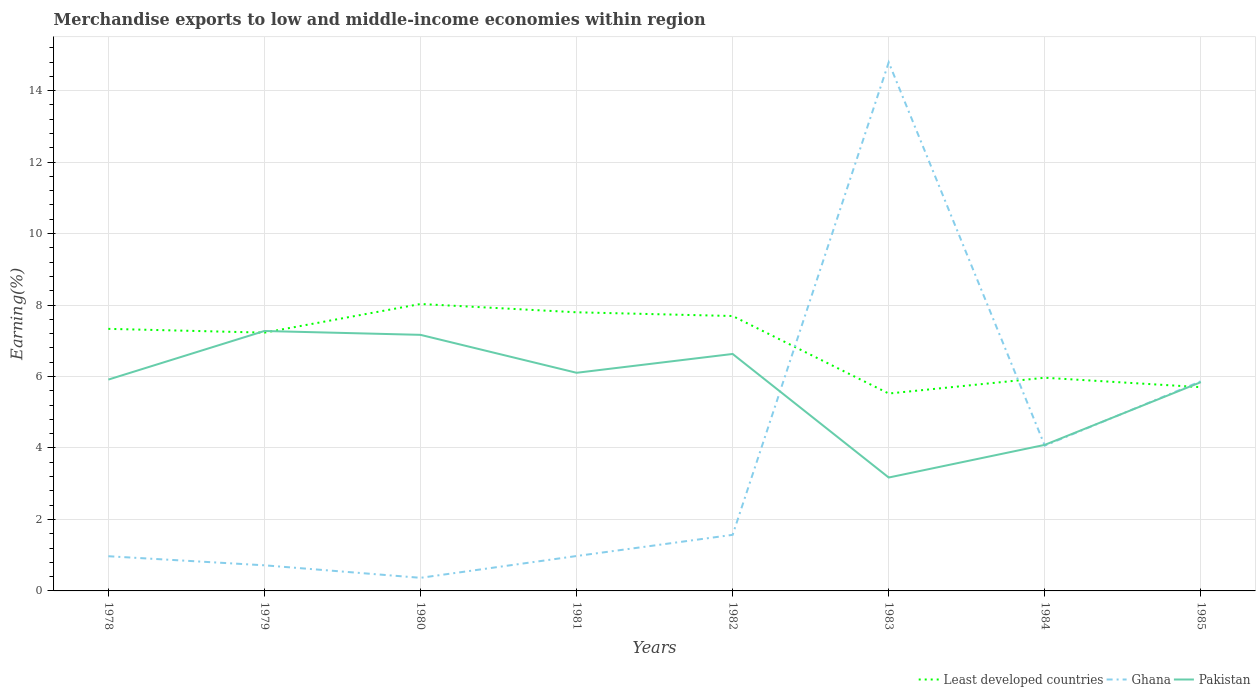How many different coloured lines are there?
Your answer should be compact. 3. Does the line corresponding to Ghana intersect with the line corresponding to Pakistan?
Your answer should be very brief. Yes. Across all years, what is the maximum percentage of amount earned from merchandise exports in Pakistan?
Give a very brief answer. 3.17. In which year was the percentage of amount earned from merchandise exports in Pakistan maximum?
Give a very brief answer. 1983. What is the total percentage of amount earned from merchandise exports in Pakistan in the graph?
Offer a very short reply. 3.08. What is the difference between the highest and the second highest percentage of amount earned from merchandise exports in Least developed countries?
Ensure brevity in your answer.  2.51. What is the difference between the highest and the lowest percentage of amount earned from merchandise exports in Ghana?
Offer a very short reply. 3. Is the percentage of amount earned from merchandise exports in Ghana strictly greater than the percentage of amount earned from merchandise exports in Pakistan over the years?
Your response must be concise. No. Does the graph contain any zero values?
Keep it short and to the point. No. Does the graph contain grids?
Offer a very short reply. Yes. Where does the legend appear in the graph?
Offer a terse response. Bottom right. How many legend labels are there?
Your answer should be compact. 3. How are the legend labels stacked?
Your answer should be very brief. Horizontal. What is the title of the graph?
Give a very brief answer. Merchandise exports to low and middle-income economies within region. Does "Argentina" appear as one of the legend labels in the graph?
Keep it short and to the point. No. What is the label or title of the Y-axis?
Make the answer very short. Earning(%). What is the Earning(%) in Least developed countries in 1978?
Offer a very short reply. 7.33. What is the Earning(%) in Ghana in 1978?
Offer a very short reply. 0.97. What is the Earning(%) of Pakistan in 1978?
Your answer should be compact. 5.91. What is the Earning(%) in Least developed countries in 1979?
Your answer should be very brief. 7.23. What is the Earning(%) in Ghana in 1979?
Your answer should be compact. 0.72. What is the Earning(%) in Pakistan in 1979?
Offer a very short reply. 7.27. What is the Earning(%) in Least developed countries in 1980?
Offer a very short reply. 8.03. What is the Earning(%) in Ghana in 1980?
Provide a short and direct response. 0.37. What is the Earning(%) of Pakistan in 1980?
Keep it short and to the point. 7.17. What is the Earning(%) of Least developed countries in 1981?
Your answer should be compact. 7.8. What is the Earning(%) of Ghana in 1981?
Provide a succinct answer. 0.98. What is the Earning(%) of Pakistan in 1981?
Provide a succinct answer. 6.1. What is the Earning(%) of Least developed countries in 1982?
Offer a terse response. 7.69. What is the Earning(%) of Ghana in 1982?
Your response must be concise. 1.57. What is the Earning(%) of Pakistan in 1982?
Provide a short and direct response. 6.63. What is the Earning(%) in Least developed countries in 1983?
Ensure brevity in your answer.  5.52. What is the Earning(%) of Ghana in 1983?
Provide a short and direct response. 14.79. What is the Earning(%) of Pakistan in 1983?
Your response must be concise. 3.17. What is the Earning(%) of Least developed countries in 1984?
Provide a short and direct response. 5.97. What is the Earning(%) of Ghana in 1984?
Offer a terse response. 4.07. What is the Earning(%) of Pakistan in 1984?
Provide a short and direct response. 4.09. What is the Earning(%) of Least developed countries in 1985?
Ensure brevity in your answer.  5.7. What is the Earning(%) of Ghana in 1985?
Your answer should be compact. 5.87. What is the Earning(%) in Pakistan in 1985?
Your answer should be compact. 5.84. Across all years, what is the maximum Earning(%) of Least developed countries?
Your response must be concise. 8.03. Across all years, what is the maximum Earning(%) of Ghana?
Ensure brevity in your answer.  14.79. Across all years, what is the maximum Earning(%) of Pakistan?
Your answer should be compact. 7.27. Across all years, what is the minimum Earning(%) in Least developed countries?
Your response must be concise. 5.52. Across all years, what is the minimum Earning(%) in Ghana?
Provide a succinct answer. 0.37. Across all years, what is the minimum Earning(%) of Pakistan?
Your response must be concise. 3.17. What is the total Earning(%) in Least developed countries in the graph?
Provide a succinct answer. 55.27. What is the total Earning(%) in Ghana in the graph?
Offer a terse response. 29.32. What is the total Earning(%) in Pakistan in the graph?
Your answer should be very brief. 46.19. What is the difference between the Earning(%) of Least developed countries in 1978 and that in 1979?
Ensure brevity in your answer.  0.11. What is the difference between the Earning(%) of Ghana in 1978 and that in 1979?
Your answer should be very brief. 0.25. What is the difference between the Earning(%) of Pakistan in 1978 and that in 1979?
Your answer should be compact. -1.36. What is the difference between the Earning(%) of Least developed countries in 1978 and that in 1980?
Your answer should be compact. -0.7. What is the difference between the Earning(%) of Ghana in 1978 and that in 1980?
Provide a short and direct response. 0.6. What is the difference between the Earning(%) of Pakistan in 1978 and that in 1980?
Make the answer very short. -1.25. What is the difference between the Earning(%) in Least developed countries in 1978 and that in 1981?
Offer a terse response. -0.46. What is the difference between the Earning(%) in Ghana in 1978 and that in 1981?
Keep it short and to the point. -0.01. What is the difference between the Earning(%) in Pakistan in 1978 and that in 1981?
Your response must be concise. -0.19. What is the difference between the Earning(%) of Least developed countries in 1978 and that in 1982?
Provide a short and direct response. -0.36. What is the difference between the Earning(%) of Ghana in 1978 and that in 1982?
Make the answer very short. -0.6. What is the difference between the Earning(%) in Pakistan in 1978 and that in 1982?
Your answer should be very brief. -0.72. What is the difference between the Earning(%) in Least developed countries in 1978 and that in 1983?
Provide a succinct answer. 1.81. What is the difference between the Earning(%) of Ghana in 1978 and that in 1983?
Keep it short and to the point. -13.82. What is the difference between the Earning(%) in Pakistan in 1978 and that in 1983?
Provide a succinct answer. 2.74. What is the difference between the Earning(%) in Least developed countries in 1978 and that in 1984?
Offer a terse response. 1.37. What is the difference between the Earning(%) of Ghana in 1978 and that in 1984?
Give a very brief answer. -3.1. What is the difference between the Earning(%) in Pakistan in 1978 and that in 1984?
Keep it short and to the point. 1.83. What is the difference between the Earning(%) of Least developed countries in 1978 and that in 1985?
Ensure brevity in your answer.  1.63. What is the difference between the Earning(%) of Ghana in 1978 and that in 1985?
Provide a short and direct response. -4.9. What is the difference between the Earning(%) of Pakistan in 1978 and that in 1985?
Offer a terse response. 0.07. What is the difference between the Earning(%) of Least developed countries in 1979 and that in 1980?
Your answer should be compact. -0.8. What is the difference between the Earning(%) in Ghana in 1979 and that in 1980?
Keep it short and to the point. 0.35. What is the difference between the Earning(%) of Pakistan in 1979 and that in 1980?
Your response must be concise. 0.11. What is the difference between the Earning(%) in Least developed countries in 1979 and that in 1981?
Ensure brevity in your answer.  -0.57. What is the difference between the Earning(%) of Ghana in 1979 and that in 1981?
Provide a short and direct response. -0.26. What is the difference between the Earning(%) of Pakistan in 1979 and that in 1981?
Your response must be concise. 1.17. What is the difference between the Earning(%) of Least developed countries in 1979 and that in 1982?
Make the answer very short. -0.46. What is the difference between the Earning(%) in Ghana in 1979 and that in 1982?
Provide a succinct answer. -0.85. What is the difference between the Earning(%) of Pakistan in 1979 and that in 1982?
Provide a succinct answer. 0.64. What is the difference between the Earning(%) of Least developed countries in 1979 and that in 1983?
Your answer should be compact. 1.7. What is the difference between the Earning(%) of Ghana in 1979 and that in 1983?
Make the answer very short. -14.07. What is the difference between the Earning(%) of Pakistan in 1979 and that in 1983?
Your answer should be compact. 4.1. What is the difference between the Earning(%) in Least developed countries in 1979 and that in 1984?
Make the answer very short. 1.26. What is the difference between the Earning(%) of Ghana in 1979 and that in 1984?
Give a very brief answer. -3.35. What is the difference between the Earning(%) in Pakistan in 1979 and that in 1984?
Provide a succinct answer. 3.19. What is the difference between the Earning(%) of Least developed countries in 1979 and that in 1985?
Provide a succinct answer. 1.53. What is the difference between the Earning(%) in Ghana in 1979 and that in 1985?
Your answer should be very brief. -5.15. What is the difference between the Earning(%) in Pakistan in 1979 and that in 1985?
Provide a short and direct response. 1.43. What is the difference between the Earning(%) in Least developed countries in 1980 and that in 1981?
Provide a succinct answer. 0.23. What is the difference between the Earning(%) of Ghana in 1980 and that in 1981?
Provide a short and direct response. -0.61. What is the difference between the Earning(%) of Pakistan in 1980 and that in 1981?
Ensure brevity in your answer.  1.06. What is the difference between the Earning(%) of Least developed countries in 1980 and that in 1982?
Ensure brevity in your answer.  0.34. What is the difference between the Earning(%) in Ghana in 1980 and that in 1982?
Make the answer very short. -1.2. What is the difference between the Earning(%) in Pakistan in 1980 and that in 1982?
Provide a short and direct response. 0.53. What is the difference between the Earning(%) of Least developed countries in 1980 and that in 1983?
Your answer should be very brief. 2.51. What is the difference between the Earning(%) in Ghana in 1980 and that in 1983?
Ensure brevity in your answer.  -14.42. What is the difference between the Earning(%) in Pakistan in 1980 and that in 1983?
Provide a short and direct response. 3.99. What is the difference between the Earning(%) in Least developed countries in 1980 and that in 1984?
Ensure brevity in your answer.  2.06. What is the difference between the Earning(%) in Ghana in 1980 and that in 1984?
Offer a terse response. -3.7. What is the difference between the Earning(%) in Pakistan in 1980 and that in 1984?
Your response must be concise. 3.08. What is the difference between the Earning(%) of Least developed countries in 1980 and that in 1985?
Give a very brief answer. 2.33. What is the difference between the Earning(%) in Ghana in 1980 and that in 1985?
Ensure brevity in your answer.  -5.5. What is the difference between the Earning(%) of Pakistan in 1980 and that in 1985?
Keep it short and to the point. 1.32. What is the difference between the Earning(%) in Least developed countries in 1981 and that in 1982?
Ensure brevity in your answer.  0.1. What is the difference between the Earning(%) of Ghana in 1981 and that in 1982?
Offer a very short reply. -0.59. What is the difference between the Earning(%) of Pakistan in 1981 and that in 1982?
Ensure brevity in your answer.  -0.53. What is the difference between the Earning(%) in Least developed countries in 1981 and that in 1983?
Offer a very short reply. 2.27. What is the difference between the Earning(%) in Ghana in 1981 and that in 1983?
Ensure brevity in your answer.  -13.81. What is the difference between the Earning(%) of Pakistan in 1981 and that in 1983?
Make the answer very short. 2.93. What is the difference between the Earning(%) of Least developed countries in 1981 and that in 1984?
Provide a short and direct response. 1.83. What is the difference between the Earning(%) in Ghana in 1981 and that in 1984?
Your answer should be very brief. -3.09. What is the difference between the Earning(%) of Pakistan in 1981 and that in 1984?
Ensure brevity in your answer.  2.02. What is the difference between the Earning(%) in Least developed countries in 1981 and that in 1985?
Ensure brevity in your answer.  2.1. What is the difference between the Earning(%) in Ghana in 1981 and that in 1985?
Make the answer very short. -4.89. What is the difference between the Earning(%) of Pakistan in 1981 and that in 1985?
Keep it short and to the point. 0.26. What is the difference between the Earning(%) in Least developed countries in 1982 and that in 1983?
Offer a terse response. 2.17. What is the difference between the Earning(%) of Ghana in 1982 and that in 1983?
Keep it short and to the point. -13.22. What is the difference between the Earning(%) in Pakistan in 1982 and that in 1983?
Ensure brevity in your answer.  3.46. What is the difference between the Earning(%) in Least developed countries in 1982 and that in 1984?
Your response must be concise. 1.73. What is the difference between the Earning(%) in Ghana in 1982 and that in 1984?
Make the answer very short. -2.5. What is the difference between the Earning(%) in Pakistan in 1982 and that in 1984?
Give a very brief answer. 2.54. What is the difference between the Earning(%) in Least developed countries in 1982 and that in 1985?
Give a very brief answer. 1.99. What is the difference between the Earning(%) in Ghana in 1982 and that in 1985?
Offer a very short reply. -4.3. What is the difference between the Earning(%) of Pakistan in 1982 and that in 1985?
Provide a short and direct response. 0.79. What is the difference between the Earning(%) of Least developed countries in 1983 and that in 1984?
Make the answer very short. -0.44. What is the difference between the Earning(%) in Ghana in 1983 and that in 1984?
Ensure brevity in your answer.  10.73. What is the difference between the Earning(%) of Pakistan in 1983 and that in 1984?
Offer a terse response. -0.91. What is the difference between the Earning(%) of Least developed countries in 1983 and that in 1985?
Offer a terse response. -0.18. What is the difference between the Earning(%) of Ghana in 1983 and that in 1985?
Keep it short and to the point. 8.92. What is the difference between the Earning(%) in Pakistan in 1983 and that in 1985?
Give a very brief answer. -2.67. What is the difference between the Earning(%) of Least developed countries in 1984 and that in 1985?
Provide a short and direct response. 0.26. What is the difference between the Earning(%) of Ghana in 1984 and that in 1985?
Make the answer very short. -1.8. What is the difference between the Earning(%) of Pakistan in 1984 and that in 1985?
Make the answer very short. -1.76. What is the difference between the Earning(%) in Least developed countries in 1978 and the Earning(%) in Ghana in 1979?
Ensure brevity in your answer.  6.62. What is the difference between the Earning(%) of Least developed countries in 1978 and the Earning(%) of Pakistan in 1979?
Your answer should be compact. 0.06. What is the difference between the Earning(%) in Ghana in 1978 and the Earning(%) in Pakistan in 1979?
Keep it short and to the point. -6.3. What is the difference between the Earning(%) in Least developed countries in 1978 and the Earning(%) in Ghana in 1980?
Give a very brief answer. 6.97. What is the difference between the Earning(%) of Least developed countries in 1978 and the Earning(%) of Pakistan in 1980?
Offer a very short reply. 0.17. What is the difference between the Earning(%) in Ghana in 1978 and the Earning(%) in Pakistan in 1980?
Your answer should be very brief. -6.2. What is the difference between the Earning(%) of Least developed countries in 1978 and the Earning(%) of Ghana in 1981?
Your answer should be compact. 6.36. What is the difference between the Earning(%) of Least developed countries in 1978 and the Earning(%) of Pakistan in 1981?
Provide a succinct answer. 1.23. What is the difference between the Earning(%) in Ghana in 1978 and the Earning(%) in Pakistan in 1981?
Offer a very short reply. -5.13. What is the difference between the Earning(%) in Least developed countries in 1978 and the Earning(%) in Ghana in 1982?
Provide a short and direct response. 5.76. What is the difference between the Earning(%) of Least developed countries in 1978 and the Earning(%) of Pakistan in 1982?
Provide a short and direct response. 0.7. What is the difference between the Earning(%) in Ghana in 1978 and the Earning(%) in Pakistan in 1982?
Ensure brevity in your answer.  -5.66. What is the difference between the Earning(%) of Least developed countries in 1978 and the Earning(%) of Ghana in 1983?
Provide a short and direct response. -7.46. What is the difference between the Earning(%) in Least developed countries in 1978 and the Earning(%) in Pakistan in 1983?
Keep it short and to the point. 4.16. What is the difference between the Earning(%) in Ghana in 1978 and the Earning(%) in Pakistan in 1983?
Your answer should be very brief. -2.2. What is the difference between the Earning(%) in Least developed countries in 1978 and the Earning(%) in Ghana in 1984?
Your answer should be very brief. 3.27. What is the difference between the Earning(%) of Least developed countries in 1978 and the Earning(%) of Pakistan in 1984?
Your answer should be very brief. 3.25. What is the difference between the Earning(%) of Ghana in 1978 and the Earning(%) of Pakistan in 1984?
Ensure brevity in your answer.  -3.12. What is the difference between the Earning(%) of Least developed countries in 1978 and the Earning(%) of Ghana in 1985?
Give a very brief answer. 1.47. What is the difference between the Earning(%) of Least developed countries in 1978 and the Earning(%) of Pakistan in 1985?
Give a very brief answer. 1.49. What is the difference between the Earning(%) of Ghana in 1978 and the Earning(%) of Pakistan in 1985?
Make the answer very short. -4.87. What is the difference between the Earning(%) of Least developed countries in 1979 and the Earning(%) of Ghana in 1980?
Provide a short and direct response. 6.86. What is the difference between the Earning(%) in Least developed countries in 1979 and the Earning(%) in Pakistan in 1980?
Provide a succinct answer. 0.06. What is the difference between the Earning(%) of Ghana in 1979 and the Earning(%) of Pakistan in 1980?
Make the answer very short. -6.45. What is the difference between the Earning(%) of Least developed countries in 1979 and the Earning(%) of Ghana in 1981?
Your response must be concise. 6.25. What is the difference between the Earning(%) in Least developed countries in 1979 and the Earning(%) in Pakistan in 1981?
Provide a succinct answer. 1.12. What is the difference between the Earning(%) in Ghana in 1979 and the Earning(%) in Pakistan in 1981?
Ensure brevity in your answer.  -5.39. What is the difference between the Earning(%) of Least developed countries in 1979 and the Earning(%) of Ghana in 1982?
Offer a terse response. 5.66. What is the difference between the Earning(%) in Least developed countries in 1979 and the Earning(%) in Pakistan in 1982?
Offer a very short reply. 0.6. What is the difference between the Earning(%) in Ghana in 1979 and the Earning(%) in Pakistan in 1982?
Provide a succinct answer. -5.91. What is the difference between the Earning(%) in Least developed countries in 1979 and the Earning(%) in Ghana in 1983?
Your answer should be very brief. -7.56. What is the difference between the Earning(%) in Least developed countries in 1979 and the Earning(%) in Pakistan in 1983?
Your response must be concise. 4.05. What is the difference between the Earning(%) in Ghana in 1979 and the Earning(%) in Pakistan in 1983?
Keep it short and to the point. -2.46. What is the difference between the Earning(%) in Least developed countries in 1979 and the Earning(%) in Ghana in 1984?
Provide a succinct answer. 3.16. What is the difference between the Earning(%) of Least developed countries in 1979 and the Earning(%) of Pakistan in 1984?
Your answer should be compact. 3.14. What is the difference between the Earning(%) of Ghana in 1979 and the Earning(%) of Pakistan in 1984?
Provide a short and direct response. -3.37. What is the difference between the Earning(%) of Least developed countries in 1979 and the Earning(%) of Ghana in 1985?
Your response must be concise. 1.36. What is the difference between the Earning(%) of Least developed countries in 1979 and the Earning(%) of Pakistan in 1985?
Ensure brevity in your answer.  1.39. What is the difference between the Earning(%) in Ghana in 1979 and the Earning(%) in Pakistan in 1985?
Offer a terse response. -5.13. What is the difference between the Earning(%) in Least developed countries in 1980 and the Earning(%) in Ghana in 1981?
Make the answer very short. 7.05. What is the difference between the Earning(%) of Least developed countries in 1980 and the Earning(%) of Pakistan in 1981?
Your answer should be very brief. 1.93. What is the difference between the Earning(%) of Ghana in 1980 and the Earning(%) of Pakistan in 1981?
Offer a very short reply. -5.74. What is the difference between the Earning(%) of Least developed countries in 1980 and the Earning(%) of Ghana in 1982?
Your answer should be compact. 6.46. What is the difference between the Earning(%) of Least developed countries in 1980 and the Earning(%) of Pakistan in 1982?
Your answer should be compact. 1.4. What is the difference between the Earning(%) of Ghana in 1980 and the Earning(%) of Pakistan in 1982?
Make the answer very short. -6.26. What is the difference between the Earning(%) of Least developed countries in 1980 and the Earning(%) of Ghana in 1983?
Your response must be concise. -6.76. What is the difference between the Earning(%) in Least developed countries in 1980 and the Earning(%) in Pakistan in 1983?
Keep it short and to the point. 4.86. What is the difference between the Earning(%) in Ghana in 1980 and the Earning(%) in Pakistan in 1983?
Give a very brief answer. -2.81. What is the difference between the Earning(%) in Least developed countries in 1980 and the Earning(%) in Ghana in 1984?
Your answer should be very brief. 3.96. What is the difference between the Earning(%) in Least developed countries in 1980 and the Earning(%) in Pakistan in 1984?
Make the answer very short. 3.94. What is the difference between the Earning(%) of Ghana in 1980 and the Earning(%) of Pakistan in 1984?
Provide a succinct answer. -3.72. What is the difference between the Earning(%) in Least developed countries in 1980 and the Earning(%) in Ghana in 1985?
Provide a succinct answer. 2.16. What is the difference between the Earning(%) in Least developed countries in 1980 and the Earning(%) in Pakistan in 1985?
Provide a succinct answer. 2.19. What is the difference between the Earning(%) of Ghana in 1980 and the Earning(%) of Pakistan in 1985?
Provide a succinct answer. -5.48. What is the difference between the Earning(%) of Least developed countries in 1981 and the Earning(%) of Ghana in 1982?
Give a very brief answer. 6.23. What is the difference between the Earning(%) in Least developed countries in 1981 and the Earning(%) in Pakistan in 1982?
Ensure brevity in your answer.  1.17. What is the difference between the Earning(%) of Ghana in 1981 and the Earning(%) of Pakistan in 1982?
Make the answer very short. -5.65. What is the difference between the Earning(%) of Least developed countries in 1981 and the Earning(%) of Ghana in 1983?
Make the answer very short. -6.99. What is the difference between the Earning(%) in Least developed countries in 1981 and the Earning(%) in Pakistan in 1983?
Give a very brief answer. 4.62. What is the difference between the Earning(%) of Ghana in 1981 and the Earning(%) of Pakistan in 1983?
Your answer should be compact. -2.2. What is the difference between the Earning(%) of Least developed countries in 1981 and the Earning(%) of Ghana in 1984?
Provide a succinct answer. 3.73. What is the difference between the Earning(%) of Least developed countries in 1981 and the Earning(%) of Pakistan in 1984?
Give a very brief answer. 3.71. What is the difference between the Earning(%) in Ghana in 1981 and the Earning(%) in Pakistan in 1984?
Make the answer very short. -3.11. What is the difference between the Earning(%) of Least developed countries in 1981 and the Earning(%) of Ghana in 1985?
Provide a short and direct response. 1.93. What is the difference between the Earning(%) in Least developed countries in 1981 and the Earning(%) in Pakistan in 1985?
Provide a succinct answer. 1.95. What is the difference between the Earning(%) in Ghana in 1981 and the Earning(%) in Pakistan in 1985?
Offer a terse response. -4.87. What is the difference between the Earning(%) of Least developed countries in 1982 and the Earning(%) of Ghana in 1983?
Offer a terse response. -7.1. What is the difference between the Earning(%) in Least developed countries in 1982 and the Earning(%) in Pakistan in 1983?
Offer a terse response. 4.52. What is the difference between the Earning(%) in Ghana in 1982 and the Earning(%) in Pakistan in 1983?
Provide a succinct answer. -1.6. What is the difference between the Earning(%) in Least developed countries in 1982 and the Earning(%) in Ghana in 1984?
Provide a succinct answer. 3.63. What is the difference between the Earning(%) of Least developed countries in 1982 and the Earning(%) of Pakistan in 1984?
Offer a very short reply. 3.61. What is the difference between the Earning(%) of Ghana in 1982 and the Earning(%) of Pakistan in 1984?
Your answer should be compact. -2.52. What is the difference between the Earning(%) in Least developed countries in 1982 and the Earning(%) in Ghana in 1985?
Keep it short and to the point. 1.83. What is the difference between the Earning(%) in Least developed countries in 1982 and the Earning(%) in Pakistan in 1985?
Ensure brevity in your answer.  1.85. What is the difference between the Earning(%) in Ghana in 1982 and the Earning(%) in Pakistan in 1985?
Offer a terse response. -4.27. What is the difference between the Earning(%) in Least developed countries in 1983 and the Earning(%) in Ghana in 1984?
Provide a succinct answer. 1.46. What is the difference between the Earning(%) of Least developed countries in 1983 and the Earning(%) of Pakistan in 1984?
Provide a short and direct response. 1.44. What is the difference between the Earning(%) in Ghana in 1983 and the Earning(%) in Pakistan in 1984?
Offer a terse response. 10.7. What is the difference between the Earning(%) in Least developed countries in 1983 and the Earning(%) in Ghana in 1985?
Provide a short and direct response. -0.34. What is the difference between the Earning(%) in Least developed countries in 1983 and the Earning(%) in Pakistan in 1985?
Provide a short and direct response. -0.32. What is the difference between the Earning(%) in Ghana in 1983 and the Earning(%) in Pakistan in 1985?
Offer a terse response. 8.95. What is the difference between the Earning(%) in Least developed countries in 1984 and the Earning(%) in Ghana in 1985?
Your answer should be compact. 0.1. What is the difference between the Earning(%) of Least developed countries in 1984 and the Earning(%) of Pakistan in 1985?
Provide a short and direct response. 0.12. What is the difference between the Earning(%) of Ghana in 1984 and the Earning(%) of Pakistan in 1985?
Offer a very short reply. -1.78. What is the average Earning(%) in Least developed countries per year?
Offer a terse response. 6.91. What is the average Earning(%) of Ghana per year?
Keep it short and to the point. 3.67. What is the average Earning(%) of Pakistan per year?
Offer a terse response. 5.77. In the year 1978, what is the difference between the Earning(%) of Least developed countries and Earning(%) of Ghana?
Provide a short and direct response. 6.36. In the year 1978, what is the difference between the Earning(%) of Least developed countries and Earning(%) of Pakistan?
Your answer should be compact. 1.42. In the year 1978, what is the difference between the Earning(%) of Ghana and Earning(%) of Pakistan?
Provide a succinct answer. -4.94. In the year 1979, what is the difference between the Earning(%) in Least developed countries and Earning(%) in Ghana?
Keep it short and to the point. 6.51. In the year 1979, what is the difference between the Earning(%) of Least developed countries and Earning(%) of Pakistan?
Your response must be concise. -0.05. In the year 1979, what is the difference between the Earning(%) of Ghana and Earning(%) of Pakistan?
Keep it short and to the point. -6.56. In the year 1980, what is the difference between the Earning(%) of Least developed countries and Earning(%) of Ghana?
Keep it short and to the point. 7.66. In the year 1980, what is the difference between the Earning(%) in Least developed countries and Earning(%) in Pakistan?
Your answer should be compact. 0.86. In the year 1980, what is the difference between the Earning(%) of Ghana and Earning(%) of Pakistan?
Your answer should be compact. -6.8. In the year 1981, what is the difference between the Earning(%) of Least developed countries and Earning(%) of Ghana?
Offer a very short reply. 6.82. In the year 1981, what is the difference between the Earning(%) in Least developed countries and Earning(%) in Pakistan?
Provide a succinct answer. 1.69. In the year 1981, what is the difference between the Earning(%) in Ghana and Earning(%) in Pakistan?
Make the answer very short. -5.13. In the year 1982, what is the difference between the Earning(%) in Least developed countries and Earning(%) in Ghana?
Keep it short and to the point. 6.12. In the year 1982, what is the difference between the Earning(%) of Least developed countries and Earning(%) of Pakistan?
Your answer should be compact. 1.06. In the year 1982, what is the difference between the Earning(%) in Ghana and Earning(%) in Pakistan?
Offer a very short reply. -5.06. In the year 1983, what is the difference between the Earning(%) of Least developed countries and Earning(%) of Ghana?
Give a very brief answer. -9.27. In the year 1983, what is the difference between the Earning(%) of Least developed countries and Earning(%) of Pakistan?
Keep it short and to the point. 2.35. In the year 1983, what is the difference between the Earning(%) of Ghana and Earning(%) of Pakistan?
Your response must be concise. 11.62. In the year 1984, what is the difference between the Earning(%) of Least developed countries and Earning(%) of Ghana?
Keep it short and to the point. 1.9. In the year 1984, what is the difference between the Earning(%) of Least developed countries and Earning(%) of Pakistan?
Make the answer very short. 1.88. In the year 1984, what is the difference between the Earning(%) of Ghana and Earning(%) of Pakistan?
Offer a terse response. -0.02. In the year 1985, what is the difference between the Earning(%) of Least developed countries and Earning(%) of Ghana?
Your answer should be compact. -0.17. In the year 1985, what is the difference between the Earning(%) of Least developed countries and Earning(%) of Pakistan?
Your answer should be very brief. -0.14. In the year 1985, what is the difference between the Earning(%) in Ghana and Earning(%) in Pakistan?
Keep it short and to the point. 0.03. What is the ratio of the Earning(%) of Least developed countries in 1978 to that in 1979?
Keep it short and to the point. 1.01. What is the ratio of the Earning(%) in Ghana in 1978 to that in 1979?
Your answer should be very brief. 1.35. What is the ratio of the Earning(%) in Pakistan in 1978 to that in 1979?
Ensure brevity in your answer.  0.81. What is the ratio of the Earning(%) of Least developed countries in 1978 to that in 1980?
Make the answer very short. 0.91. What is the ratio of the Earning(%) in Ghana in 1978 to that in 1980?
Offer a very short reply. 2.65. What is the ratio of the Earning(%) in Pakistan in 1978 to that in 1980?
Your answer should be very brief. 0.83. What is the ratio of the Earning(%) of Least developed countries in 1978 to that in 1981?
Your response must be concise. 0.94. What is the ratio of the Earning(%) of Pakistan in 1978 to that in 1981?
Keep it short and to the point. 0.97. What is the ratio of the Earning(%) of Least developed countries in 1978 to that in 1982?
Ensure brevity in your answer.  0.95. What is the ratio of the Earning(%) of Ghana in 1978 to that in 1982?
Ensure brevity in your answer.  0.62. What is the ratio of the Earning(%) of Pakistan in 1978 to that in 1982?
Provide a short and direct response. 0.89. What is the ratio of the Earning(%) in Least developed countries in 1978 to that in 1983?
Offer a very short reply. 1.33. What is the ratio of the Earning(%) of Ghana in 1978 to that in 1983?
Provide a short and direct response. 0.07. What is the ratio of the Earning(%) of Pakistan in 1978 to that in 1983?
Offer a terse response. 1.86. What is the ratio of the Earning(%) in Least developed countries in 1978 to that in 1984?
Your answer should be compact. 1.23. What is the ratio of the Earning(%) in Ghana in 1978 to that in 1984?
Offer a very short reply. 0.24. What is the ratio of the Earning(%) in Pakistan in 1978 to that in 1984?
Your answer should be very brief. 1.45. What is the ratio of the Earning(%) in Least developed countries in 1978 to that in 1985?
Keep it short and to the point. 1.29. What is the ratio of the Earning(%) in Ghana in 1978 to that in 1985?
Keep it short and to the point. 0.17. What is the ratio of the Earning(%) of Pakistan in 1978 to that in 1985?
Offer a terse response. 1.01. What is the ratio of the Earning(%) of Least developed countries in 1979 to that in 1980?
Ensure brevity in your answer.  0.9. What is the ratio of the Earning(%) in Ghana in 1979 to that in 1980?
Your answer should be very brief. 1.96. What is the ratio of the Earning(%) of Pakistan in 1979 to that in 1980?
Make the answer very short. 1.02. What is the ratio of the Earning(%) of Least developed countries in 1979 to that in 1981?
Your answer should be very brief. 0.93. What is the ratio of the Earning(%) in Ghana in 1979 to that in 1981?
Offer a terse response. 0.73. What is the ratio of the Earning(%) of Pakistan in 1979 to that in 1981?
Provide a succinct answer. 1.19. What is the ratio of the Earning(%) in Least developed countries in 1979 to that in 1982?
Your response must be concise. 0.94. What is the ratio of the Earning(%) of Ghana in 1979 to that in 1982?
Provide a succinct answer. 0.46. What is the ratio of the Earning(%) in Pakistan in 1979 to that in 1982?
Your answer should be very brief. 1.1. What is the ratio of the Earning(%) of Least developed countries in 1979 to that in 1983?
Provide a short and direct response. 1.31. What is the ratio of the Earning(%) in Ghana in 1979 to that in 1983?
Make the answer very short. 0.05. What is the ratio of the Earning(%) of Pakistan in 1979 to that in 1983?
Ensure brevity in your answer.  2.29. What is the ratio of the Earning(%) of Least developed countries in 1979 to that in 1984?
Keep it short and to the point. 1.21. What is the ratio of the Earning(%) in Ghana in 1979 to that in 1984?
Keep it short and to the point. 0.18. What is the ratio of the Earning(%) of Pakistan in 1979 to that in 1984?
Offer a terse response. 1.78. What is the ratio of the Earning(%) of Least developed countries in 1979 to that in 1985?
Your answer should be compact. 1.27. What is the ratio of the Earning(%) in Ghana in 1979 to that in 1985?
Keep it short and to the point. 0.12. What is the ratio of the Earning(%) of Pakistan in 1979 to that in 1985?
Offer a very short reply. 1.25. What is the ratio of the Earning(%) of Least developed countries in 1980 to that in 1981?
Provide a succinct answer. 1.03. What is the ratio of the Earning(%) in Ghana in 1980 to that in 1981?
Your answer should be very brief. 0.38. What is the ratio of the Earning(%) in Pakistan in 1980 to that in 1981?
Provide a succinct answer. 1.17. What is the ratio of the Earning(%) in Least developed countries in 1980 to that in 1982?
Give a very brief answer. 1.04. What is the ratio of the Earning(%) in Ghana in 1980 to that in 1982?
Keep it short and to the point. 0.23. What is the ratio of the Earning(%) of Pakistan in 1980 to that in 1982?
Your answer should be very brief. 1.08. What is the ratio of the Earning(%) of Least developed countries in 1980 to that in 1983?
Offer a terse response. 1.45. What is the ratio of the Earning(%) in Ghana in 1980 to that in 1983?
Give a very brief answer. 0.02. What is the ratio of the Earning(%) of Pakistan in 1980 to that in 1983?
Your response must be concise. 2.26. What is the ratio of the Earning(%) in Least developed countries in 1980 to that in 1984?
Your answer should be very brief. 1.35. What is the ratio of the Earning(%) in Ghana in 1980 to that in 1984?
Offer a very short reply. 0.09. What is the ratio of the Earning(%) of Pakistan in 1980 to that in 1984?
Offer a very short reply. 1.75. What is the ratio of the Earning(%) in Least developed countries in 1980 to that in 1985?
Your answer should be very brief. 1.41. What is the ratio of the Earning(%) in Ghana in 1980 to that in 1985?
Offer a very short reply. 0.06. What is the ratio of the Earning(%) of Pakistan in 1980 to that in 1985?
Offer a very short reply. 1.23. What is the ratio of the Earning(%) of Least developed countries in 1981 to that in 1982?
Offer a very short reply. 1.01. What is the ratio of the Earning(%) in Ghana in 1981 to that in 1982?
Give a very brief answer. 0.62. What is the ratio of the Earning(%) in Pakistan in 1981 to that in 1982?
Your response must be concise. 0.92. What is the ratio of the Earning(%) of Least developed countries in 1981 to that in 1983?
Your answer should be compact. 1.41. What is the ratio of the Earning(%) of Ghana in 1981 to that in 1983?
Your response must be concise. 0.07. What is the ratio of the Earning(%) in Pakistan in 1981 to that in 1983?
Make the answer very short. 1.92. What is the ratio of the Earning(%) in Least developed countries in 1981 to that in 1984?
Your answer should be very brief. 1.31. What is the ratio of the Earning(%) of Ghana in 1981 to that in 1984?
Keep it short and to the point. 0.24. What is the ratio of the Earning(%) in Pakistan in 1981 to that in 1984?
Offer a terse response. 1.49. What is the ratio of the Earning(%) of Least developed countries in 1981 to that in 1985?
Offer a terse response. 1.37. What is the ratio of the Earning(%) of Ghana in 1981 to that in 1985?
Give a very brief answer. 0.17. What is the ratio of the Earning(%) in Pakistan in 1981 to that in 1985?
Offer a terse response. 1.04. What is the ratio of the Earning(%) in Least developed countries in 1982 to that in 1983?
Keep it short and to the point. 1.39. What is the ratio of the Earning(%) of Ghana in 1982 to that in 1983?
Keep it short and to the point. 0.11. What is the ratio of the Earning(%) in Pakistan in 1982 to that in 1983?
Give a very brief answer. 2.09. What is the ratio of the Earning(%) in Least developed countries in 1982 to that in 1984?
Your answer should be very brief. 1.29. What is the ratio of the Earning(%) of Ghana in 1982 to that in 1984?
Your answer should be very brief. 0.39. What is the ratio of the Earning(%) of Pakistan in 1982 to that in 1984?
Offer a terse response. 1.62. What is the ratio of the Earning(%) in Least developed countries in 1982 to that in 1985?
Keep it short and to the point. 1.35. What is the ratio of the Earning(%) of Ghana in 1982 to that in 1985?
Provide a succinct answer. 0.27. What is the ratio of the Earning(%) in Pakistan in 1982 to that in 1985?
Ensure brevity in your answer.  1.14. What is the ratio of the Earning(%) of Least developed countries in 1983 to that in 1984?
Make the answer very short. 0.93. What is the ratio of the Earning(%) in Ghana in 1983 to that in 1984?
Provide a succinct answer. 3.64. What is the ratio of the Earning(%) of Pakistan in 1983 to that in 1984?
Make the answer very short. 0.78. What is the ratio of the Earning(%) of Least developed countries in 1983 to that in 1985?
Ensure brevity in your answer.  0.97. What is the ratio of the Earning(%) in Ghana in 1983 to that in 1985?
Keep it short and to the point. 2.52. What is the ratio of the Earning(%) in Pakistan in 1983 to that in 1985?
Provide a short and direct response. 0.54. What is the ratio of the Earning(%) of Least developed countries in 1984 to that in 1985?
Give a very brief answer. 1.05. What is the ratio of the Earning(%) in Ghana in 1984 to that in 1985?
Make the answer very short. 0.69. What is the ratio of the Earning(%) in Pakistan in 1984 to that in 1985?
Give a very brief answer. 0.7. What is the difference between the highest and the second highest Earning(%) in Least developed countries?
Provide a short and direct response. 0.23. What is the difference between the highest and the second highest Earning(%) in Ghana?
Keep it short and to the point. 8.92. What is the difference between the highest and the second highest Earning(%) of Pakistan?
Make the answer very short. 0.11. What is the difference between the highest and the lowest Earning(%) of Least developed countries?
Keep it short and to the point. 2.51. What is the difference between the highest and the lowest Earning(%) of Ghana?
Provide a short and direct response. 14.42. What is the difference between the highest and the lowest Earning(%) in Pakistan?
Provide a succinct answer. 4.1. 